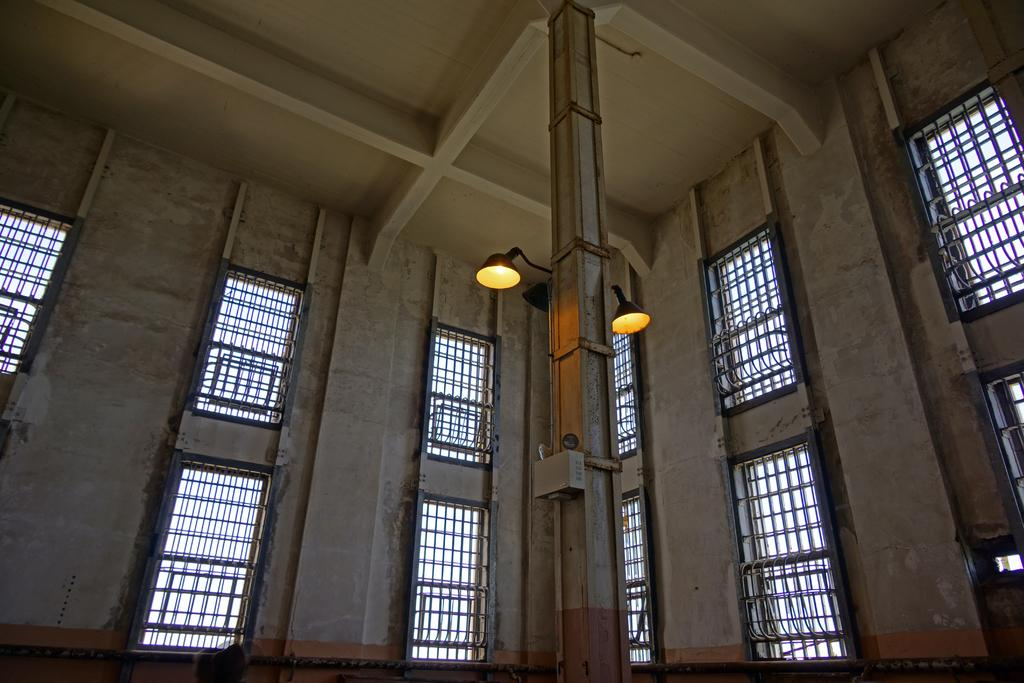What type of view is shown in the image? The image is an inside view of a building. What can be seen through the windows in the image? The image does not show what can be seen through the windows. What are the lights in the image used for? The purpose of the lights in the image is not specified. What is the pole used for in the image? The purpose of the pole in the image is not mentioned. What are the rods used for in the image? The purpose of the rods in the image is not specified. What is visible at the top of the image? There is a roof visible at the top of the image. Can you tell me how many parents are visible in the image? There are no parents visible in the image. What type of stick is being used by the dad in the image? There is no dad or stick present in the image. 